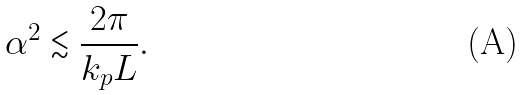<formula> <loc_0><loc_0><loc_500><loc_500>\alpha ^ { 2 } \lesssim \frac { 2 \pi } { k _ { p } L } .</formula> 